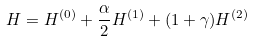<formula> <loc_0><loc_0><loc_500><loc_500>H = H ^ { ( 0 ) } + \frac { \alpha } { 2 } H ^ { ( 1 ) } + ( 1 + \gamma ) H ^ { ( 2 ) }</formula> 